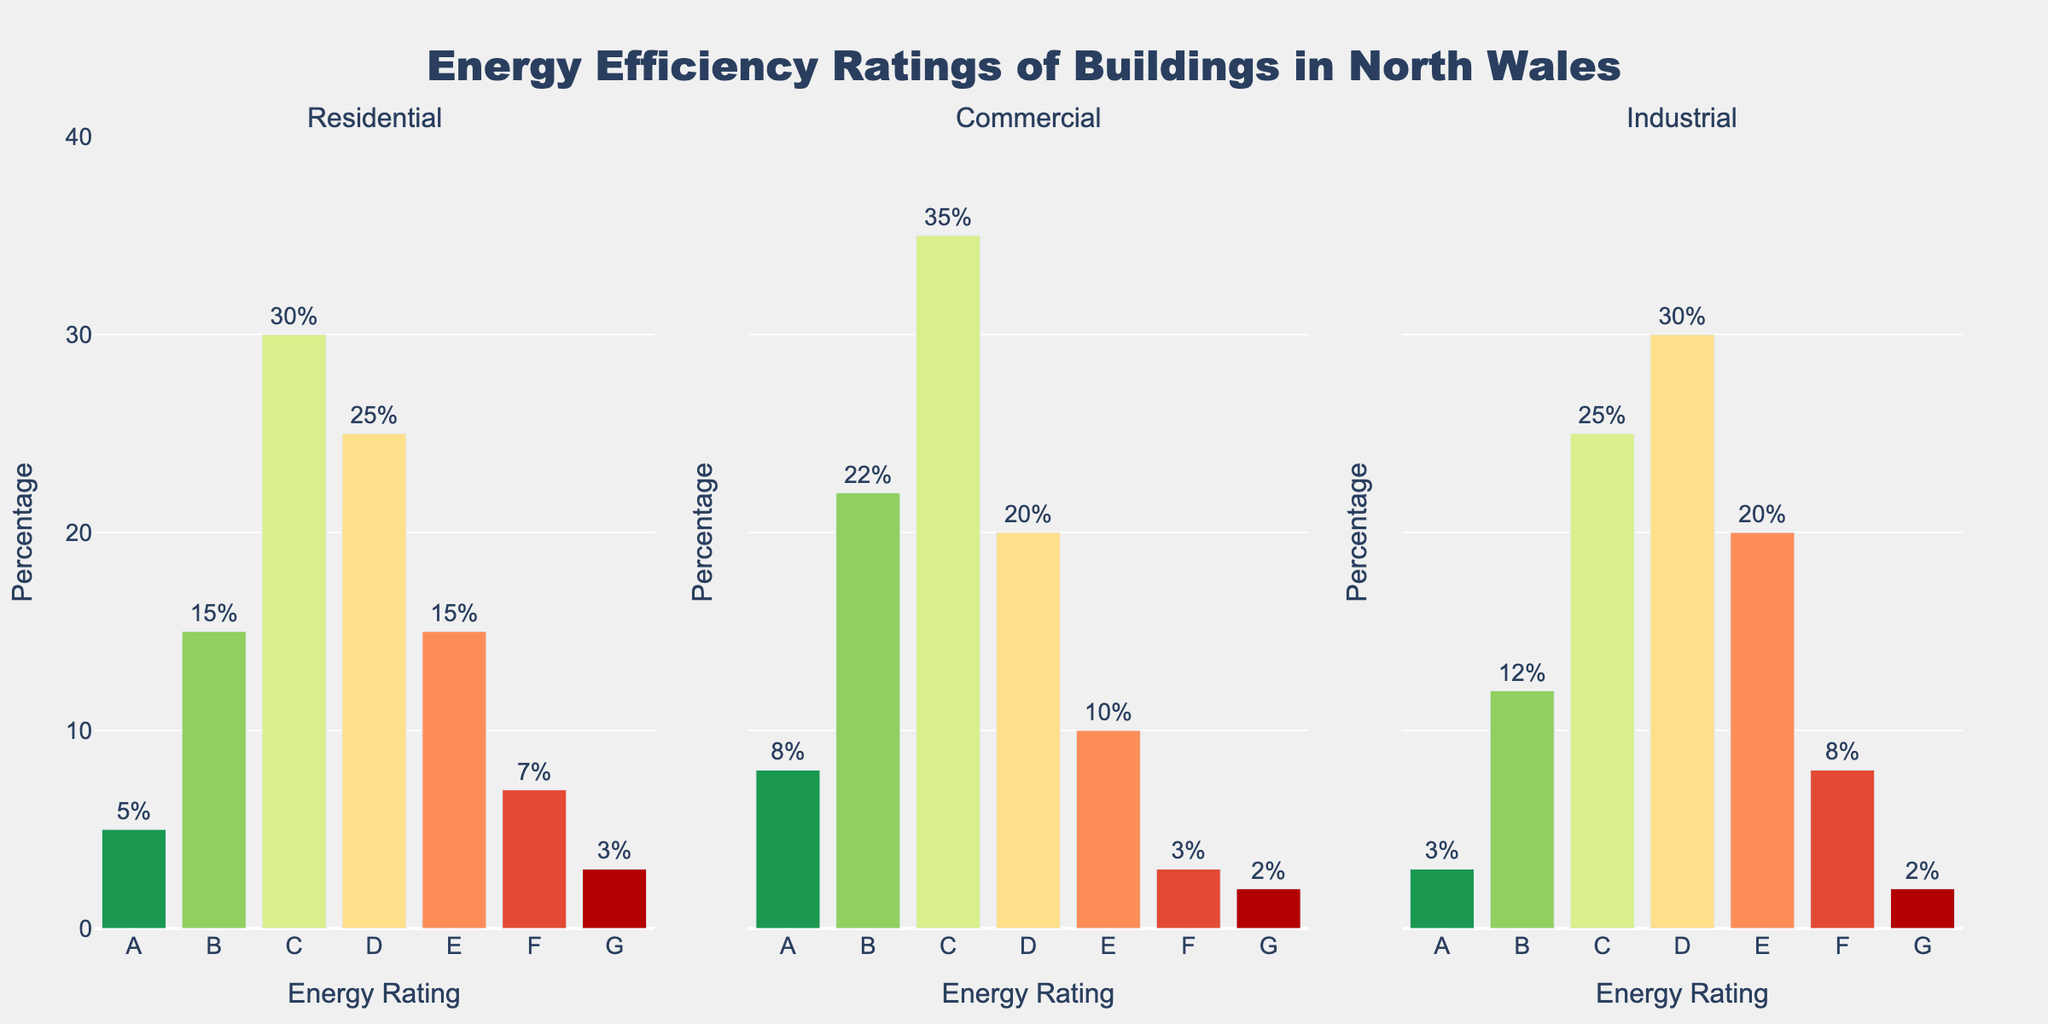What's the title of the figure? The title of the figure is located at the top of the plot, indicating what the chart represents.
Answer: Energy Efficiency Ratings of Buildings in North Wales Which building type has the highest percentage of buildings with an Energy Rating of 'C'? Check the 'C' bars across all subplots. The highest 'C' percentage is found in the Commercial segment.
Answer: Commercial What percentage of Residential buildings have an Energy Rating of 'E'? Look at the 'E' bar in the Residential subplot and identify the percentage value.
Answer: 15% How does the percentage of Industrial buildings with an Energy Rating of 'A' compare to Residential buildings? Compare the height of the 'A' bars in the Industrial and Residential subplots. They represent 3% for Industrial and 5% for Residential.
Answer: Residential has 2% more What's the total percentage of Commercial buildings with Energy Ratings of 'A', 'B', and 'C'? Sum the percentages of 'A', 'B', and 'C' bars in the Commercial subplot (8% + 22% + 35%).
Answer: 65% Which building type has the least percentage of buildings with an Energy Rating of 'G'? Check the 'G' bars across all subplots; the smallest value is in the Commercial subplot with 2%.
Answer: Commercial and Industrial (tie) What is the average percentage of Residential buildings for the ratings 'A' through 'D'? Add the percentages of 'A' through 'D' (5% + 15% + 30% + 25%) and divide by 4.
Answer: 18.75% Which energy rating has the most consistent (similar) percentage across all building types? Compare the bars for each rating across all building types. The percentages for 'G' (3%, 2%, 2%) are closest.
Answer: G What is the difference in the percentage of buildings with an Energy Rating of 'E' between Industrial and Commercial types? Subtract the 'E' percentage in Commercial from the 'E' percentage in Industrial (20% - 10%).
Answer: 10% How many unique Energy Ratings are displayed on each subplot? Each subplot shows bars labeled from 'A' to 'G'. Count these unique labels.
Answer: 7 